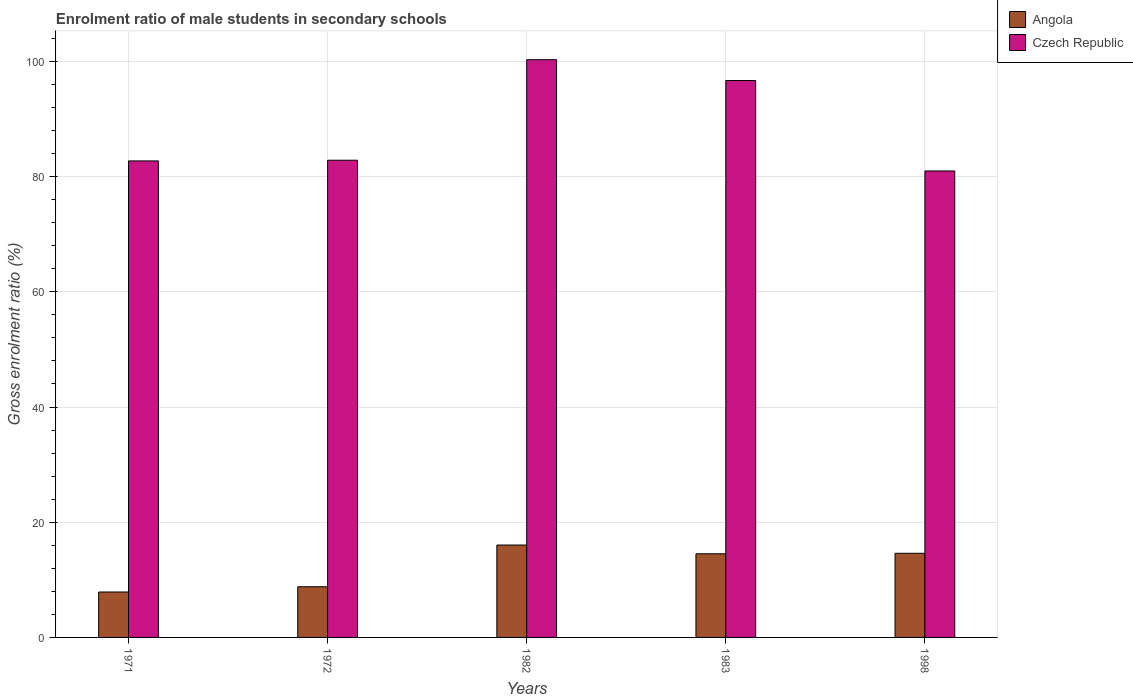How many different coloured bars are there?
Your answer should be very brief. 2. Are the number of bars on each tick of the X-axis equal?
Your response must be concise. Yes. What is the label of the 1st group of bars from the left?
Offer a very short reply. 1971. In how many cases, is the number of bars for a given year not equal to the number of legend labels?
Keep it short and to the point. 0. What is the enrolment ratio of male students in secondary schools in Angola in 1998?
Keep it short and to the point. 14.61. Across all years, what is the maximum enrolment ratio of male students in secondary schools in Angola?
Your response must be concise. 16.04. Across all years, what is the minimum enrolment ratio of male students in secondary schools in Angola?
Keep it short and to the point. 7.89. In which year was the enrolment ratio of male students in secondary schools in Czech Republic maximum?
Offer a very short reply. 1982. In which year was the enrolment ratio of male students in secondary schools in Angola minimum?
Your response must be concise. 1971. What is the total enrolment ratio of male students in secondary schools in Czech Republic in the graph?
Your response must be concise. 443.5. What is the difference between the enrolment ratio of male students in secondary schools in Czech Republic in 1983 and that in 1998?
Offer a terse response. 15.7. What is the difference between the enrolment ratio of male students in secondary schools in Angola in 1982 and the enrolment ratio of male students in secondary schools in Czech Republic in 1983?
Keep it short and to the point. -80.64. What is the average enrolment ratio of male students in secondary schools in Czech Republic per year?
Provide a short and direct response. 88.7. In the year 1972, what is the difference between the enrolment ratio of male students in secondary schools in Czech Republic and enrolment ratio of male students in secondary schools in Angola?
Ensure brevity in your answer.  74.04. In how many years, is the enrolment ratio of male students in secondary schools in Angola greater than 20 %?
Make the answer very short. 0. What is the ratio of the enrolment ratio of male students in secondary schools in Angola in 1982 to that in 1983?
Offer a terse response. 1.1. Is the difference between the enrolment ratio of male students in secondary schools in Czech Republic in 1971 and 1983 greater than the difference between the enrolment ratio of male students in secondary schools in Angola in 1971 and 1983?
Provide a succinct answer. No. What is the difference between the highest and the second highest enrolment ratio of male students in secondary schools in Czech Republic?
Provide a succinct answer. 3.61. What is the difference between the highest and the lowest enrolment ratio of male students in secondary schools in Angola?
Provide a short and direct response. 8.15. In how many years, is the enrolment ratio of male students in secondary schools in Angola greater than the average enrolment ratio of male students in secondary schools in Angola taken over all years?
Your response must be concise. 3. What does the 2nd bar from the left in 1972 represents?
Offer a very short reply. Czech Republic. What does the 1st bar from the right in 1982 represents?
Offer a terse response. Czech Republic. Are all the bars in the graph horizontal?
Provide a succinct answer. No. How many years are there in the graph?
Your answer should be compact. 5. Are the values on the major ticks of Y-axis written in scientific E-notation?
Make the answer very short. No. Does the graph contain any zero values?
Give a very brief answer. No. How many legend labels are there?
Provide a short and direct response. 2. What is the title of the graph?
Ensure brevity in your answer.  Enrolment ratio of male students in secondary schools. What is the Gross enrolment ratio (%) in Angola in 1971?
Offer a terse response. 7.89. What is the Gross enrolment ratio (%) in Czech Republic in 1971?
Your answer should be very brief. 82.72. What is the Gross enrolment ratio (%) of Angola in 1972?
Offer a terse response. 8.8. What is the Gross enrolment ratio (%) in Czech Republic in 1972?
Ensure brevity in your answer.  82.84. What is the Gross enrolment ratio (%) of Angola in 1982?
Provide a short and direct response. 16.04. What is the Gross enrolment ratio (%) of Czech Republic in 1982?
Your response must be concise. 100.29. What is the Gross enrolment ratio (%) of Angola in 1983?
Your response must be concise. 14.52. What is the Gross enrolment ratio (%) in Czech Republic in 1983?
Your answer should be very brief. 96.68. What is the Gross enrolment ratio (%) in Angola in 1998?
Ensure brevity in your answer.  14.61. What is the Gross enrolment ratio (%) in Czech Republic in 1998?
Your response must be concise. 80.98. Across all years, what is the maximum Gross enrolment ratio (%) in Angola?
Your response must be concise. 16.04. Across all years, what is the maximum Gross enrolment ratio (%) of Czech Republic?
Keep it short and to the point. 100.29. Across all years, what is the minimum Gross enrolment ratio (%) in Angola?
Give a very brief answer. 7.89. Across all years, what is the minimum Gross enrolment ratio (%) in Czech Republic?
Provide a succinct answer. 80.98. What is the total Gross enrolment ratio (%) in Angola in the graph?
Keep it short and to the point. 61.85. What is the total Gross enrolment ratio (%) of Czech Republic in the graph?
Offer a terse response. 443.5. What is the difference between the Gross enrolment ratio (%) of Angola in 1971 and that in 1972?
Your answer should be very brief. -0.91. What is the difference between the Gross enrolment ratio (%) of Czech Republic in 1971 and that in 1972?
Your answer should be compact. -0.12. What is the difference between the Gross enrolment ratio (%) of Angola in 1971 and that in 1982?
Provide a short and direct response. -8.15. What is the difference between the Gross enrolment ratio (%) of Czech Republic in 1971 and that in 1982?
Provide a short and direct response. -17.57. What is the difference between the Gross enrolment ratio (%) of Angola in 1971 and that in 1983?
Provide a short and direct response. -6.63. What is the difference between the Gross enrolment ratio (%) of Czech Republic in 1971 and that in 1983?
Keep it short and to the point. -13.96. What is the difference between the Gross enrolment ratio (%) in Angola in 1971 and that in 1998?
Offer a terse response. -6.72. What is the difference between the Gross enrolment ratio (%) in Czech Republic in 1971 and that in 1998?
Your answer should be compact. 1.75. What is the difference between the Gross enrolment ratio (%) of Angola in 1972 and that in 1982?
Provide a succinct answer. -7.24. What is the difference between the Gross enrolment ratio (%) of Czech Republic in 1972 and that in 1982?
Your answer should be compact. -17.45. What is the difference between the Gross enrolment ratio (%) in Angola in 1972 and that in 1983?
Ensure brevity in your answer.  -5.72. What is the difference between the Gross enrolment ratio (%) of Czech Republic in 1972 and that in 1983?
Provide a succinct answer. -13.84. What is the difference between the Gross enrolment ratio (%) in Angola in 1972 and that in 1998?
Keep it short and to the point. -5.81. What is the difference between the Gross enrolment ratio (%) in Czech Republic in 1972 and that in 1998?
Provide a short and direct response. 1.86. What is the difference between the Gross enrolment ratio (%) of Angola in 1982 and that in 1983?
Offer a very short reply. 1.52. What is the difference between the Gross enrolment ratio (%) in Czech Republic in 1982 and that in 1983?
Offer a terse response. 3.61. What is the difference between the Gross enrolment ratio (%) of Angola in 1982 and that in 1998?
Your answer should be compact. 1.43. What is the difference between the Gross enrolment ratio (%) in Czech Republic in 1982 and that in 1998?
Keep it short and to the point. 19.31. What is the difference between the Gross enrolment ratio (%) of Angola in 1983 and that in 1998?
Provide a succinct answer. -0.09. What is the difference between the Gross enrolment ratio (%) of Czech Republic in 1983 and that in 1998?
Offer a very short reply. 15.7. What is the difference between the Gross enrolment ratio (%) of Angola in 1971 and the Gross enrolment ratio (%) of Czech Republic in 1972?
Your answer should be compact. -74.95. What is the difference between the Gross enrolment ratio (%) of Angola in 1971 and the Gross enrolment ratio (%) of Czech Republic in 1982?
Give a very brief answer. -92.4. What is the difference between the Gross enrolment ratio (%) in Angola in 1971 and the Gross enrolment ratio (%) in Czech Republic in 1983?
Provide a succinct answer. -88.79. What is the difference between the Gross enrolment ratio (%) in Angola in 1971 and the Gross enrolment ratio (%) in Czech Republic in 1998?
Provide a short and direct response. -73.09. What is the difference between the Gross enrolment ratio (%) in Angola in 1972 and the Gross enrolment ratio (%) in Czech Republic in 1982?
Keep it short and to the point. -91.49. What is the difference between the Gross enrolment ratio (%) of Angola in 1972 and the Gross enrolment ratio (%) of Czech Republic in 1983?
Your answer should be very brief. -87.88. What is the difference between the Gross enrolment ratio (%) of Angola in 1972 and the Gross enrolment ratio (%) of Czech Republic in 1998?
Offer a very short reply. -72.18. What is the difference between the Gross enrolment ratio (%) of Angola in 1982 and the Gross enrolment ratio (%) of Czech Republic in 1983?
Ensure brevity in your answer.  -80.64. What is the difference between the Gross enrolment ratio (%) in Angola in 1982 and the Gross enrolment ratio (%) in Czech Republic in 1998?
Provide a succinct answer. -64.94. What is the difference between the Gross enrolment ratio (%) in Angola in 1983 and the Gross enrolment ratio (%) in Czech Republic in 1998?
Your response must be concise. -66.46. What is the average Gross enrolment ratio (%) of Angola per year?
Ensure brevity in your answer.  12.37. What is the average Gross enrolment ratio (%) of Czech Republic per year?
Your response must be concise. 88.7. In the year 1971, what is the difference between the Gross enrolment ratio (%) in Angola and Gross enrolment ratio (%) in Czech Republic?
Provide a succinct answer. -74.83. In the year 1972, what is the difference between the Gross enrolment ratio (%) of Angola and Gross enrolment ratio (%) of Czech Republic?
Offer a very short reply. -74.04. In the year 1982, what is the difference between the Gross enrolment ratio (%) in Angola and Gross enrolment ratio (%) in Czech Republic?
Your answer should be compact. -84.25. In the year 1983, what is the difference between the Gross enrolment ratio (%) of Angola and Gross enrolment ratio (%) of Czech Republic?
Your answer should be very brief. -82.16. In the year 1998, what is the difference between the Gross enrolment ratio (%) in Angola and Gross enrolment ratio (%) in Czech Republic?
Offer a terse response. -66.37. What is the ratio of the Gross enrolment ratio (%) in Angola in 1971 to that in 1972?
Ensure brevity in your answer.  0.9. What is the ratio of the Gross enrolment ratio (%) of Angola in 1971 to that in 1982?
Provide a succinct answer. 0.49. What is the ratio of the Gross enrolment ratio (%) of Czech Republic in 1971 to that in 1982?
Provide a succinct answer. 0.82. What is the ratio of the Gross enrolment ratio (%) of Angola in 1971 to that in 1983?
Ensure brevity in your answer.  0.54. What is the ratio of the Gross enrolment ratio (%) of Czech Republic in 1971 to that in 1983?
Ensure brevity in your answer.  0.86. What is the ratio of the Gross enrolment ratio (%) of Angola in 1971 to that in 1998?
Offer a very short reply. 0.54. What is the ratio of the Gross enrolment ratio (%) of Czech Republic in 1971 to that in 1998?
Provide a short and direct response. 1.02. What is the ratio of the Gross enrolment ratio (%) of Angola in 1972 to that in 1982?
Offer a very short reply. 0.55. What is the ratio of the Gross enrolment ratio (%) in Czech Republic in 1972 to that in 1982?
Offer a very short reply. 0.83. What is the ratio of the Gross enrolment ratio (%) of Angola in 1972 to that in 1983?
Ensure brevity in your answer.  0.61. What is the ratio of the Gross enrolment ratio (%) of Czech Republic in 1972 to that in 1983?
Give a very brief answer. 0.86. What is the ratio of the Gross enrolment ratio (%) in Angola in 1972 to that in 1998?
Keep it short and to the point. 0.6. What is the ratio of the Gross enrolment ratio (%) in Angola in 1982 to that in 1983?
Offer a terse response. 1.1. What is the ratio of the Gross enrolment ratio (%) of Czech Republic in 1982 to that in 1983?
Your answer should be compact. 1.04. What is the ratio of the Gross enrolment ratio (%) of Angola in 1982 to that in 1998?
Provide a succinct answer. 1.1. What is the ratio of the Gross enrolment ratio (%) in Czech Republic in 1982 to that in 1998?
Provide a succinct answer. 1.24. What is the ratio of the Gross enrolment ratio (%) of Angola in 1983 to that in 1998?
Provide a short and direct response. 0.99. What is the ratio of the Gross enrolment ratio (%) in Czech Republic in 1983 to that in 1998?
Provide a succinct answer. 1.19. What is the difference between the highest and the second highest Gross enrolment ratio (%) of Angola?
Your answer should be compact. 1.43. What is the difference between the highest and the second highest Gross enrolment ratio (%) in Czech Republic?
Provide a succinct answer. 3.61. What is the difference between the highest and the lowest Gross enrolment ratio (%) of Angola?
Your answer should be very brief. 8.15. What is the difference between the highest and the lowest Gross enrolment ratio (%) of Czech Republic?
Offer a very short reply. 19.31. 